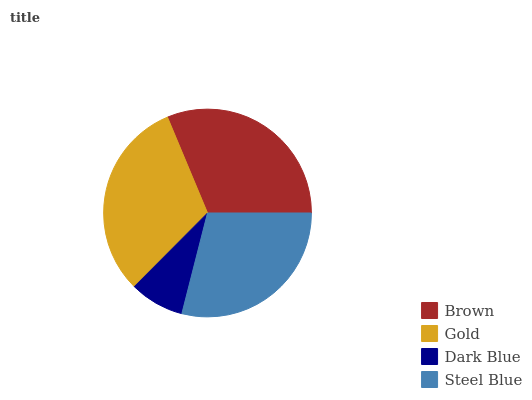Is Dark Blue the minimum?
Answer yes or no. Yes. Is Brown the maximum?
Answer yes or no. Yes. Is Gold the minimum?
Answer yes or no. No. Is Gold the maximum?
Answer yes or no. No. Is Brown greater than Gold?
Answer yes or no. Yes. Is Gold less than Brown?
Answer yes or no. Yes. Is Gold greater than Brown?
Answer yes or no. No. Is Brown less than Gold?
Answer yes or no. No. Is Gold the high median?
Answer yes or no. Yes. Is Steel Blue the low median?
Answer yes or no. Yes. Is Dark Blue the high median?
Answer yes or no. No. Is Dark Blue the low median?
Answer yes or no. No. 